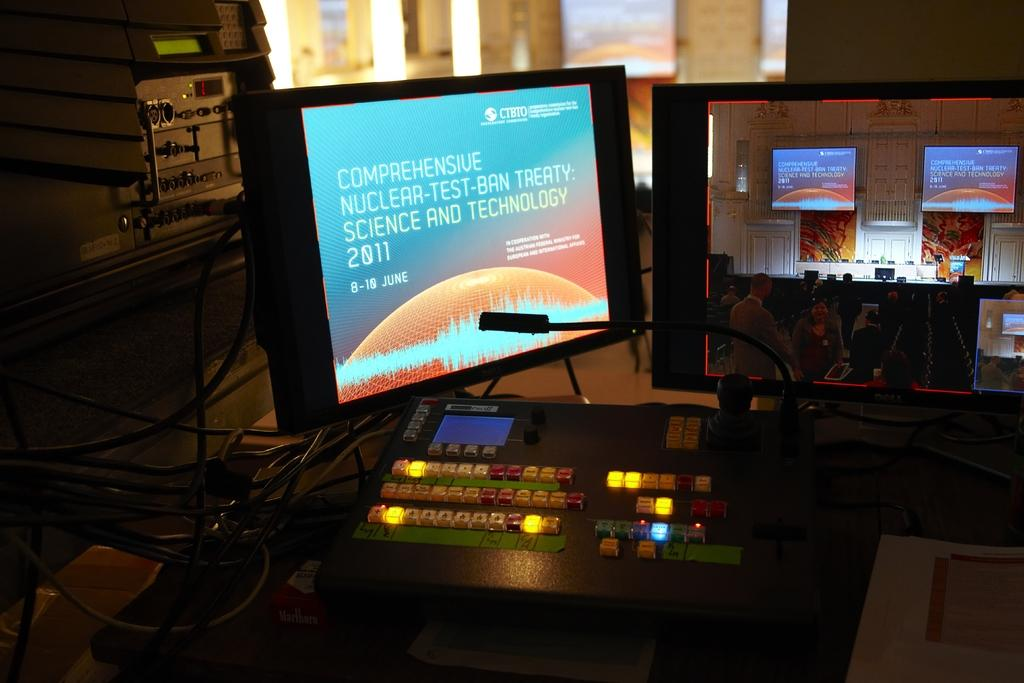<image>
Summarize the visual content of the image. computer with flat screen and the word comprehensive at the top 